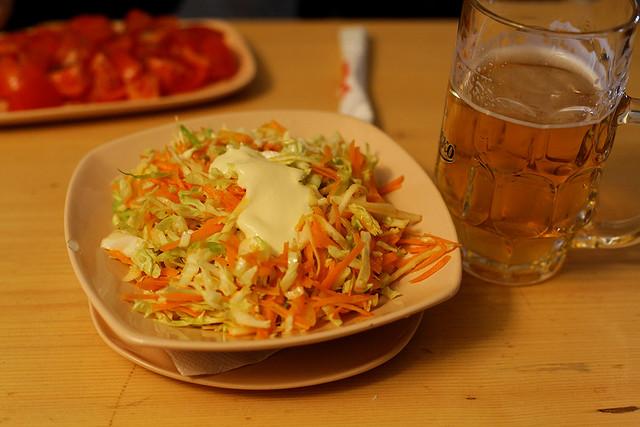What color is the beverage?
Keep it brief. Yellow. What is in the glass?
Give a very brief answer. Beer. What type of beverage is in the glass?
Write a very short answer. Beer. Is the mug full?
Concise answer only. No. Would this be a healthy meal?
Concise answer only. Yes. How much liquid is in this glass?
Short answer required. Half full. Is the bowl square or round in shape?
Write a very short answer. Square. What is mainly featured?
Concise answer only. Salad. 